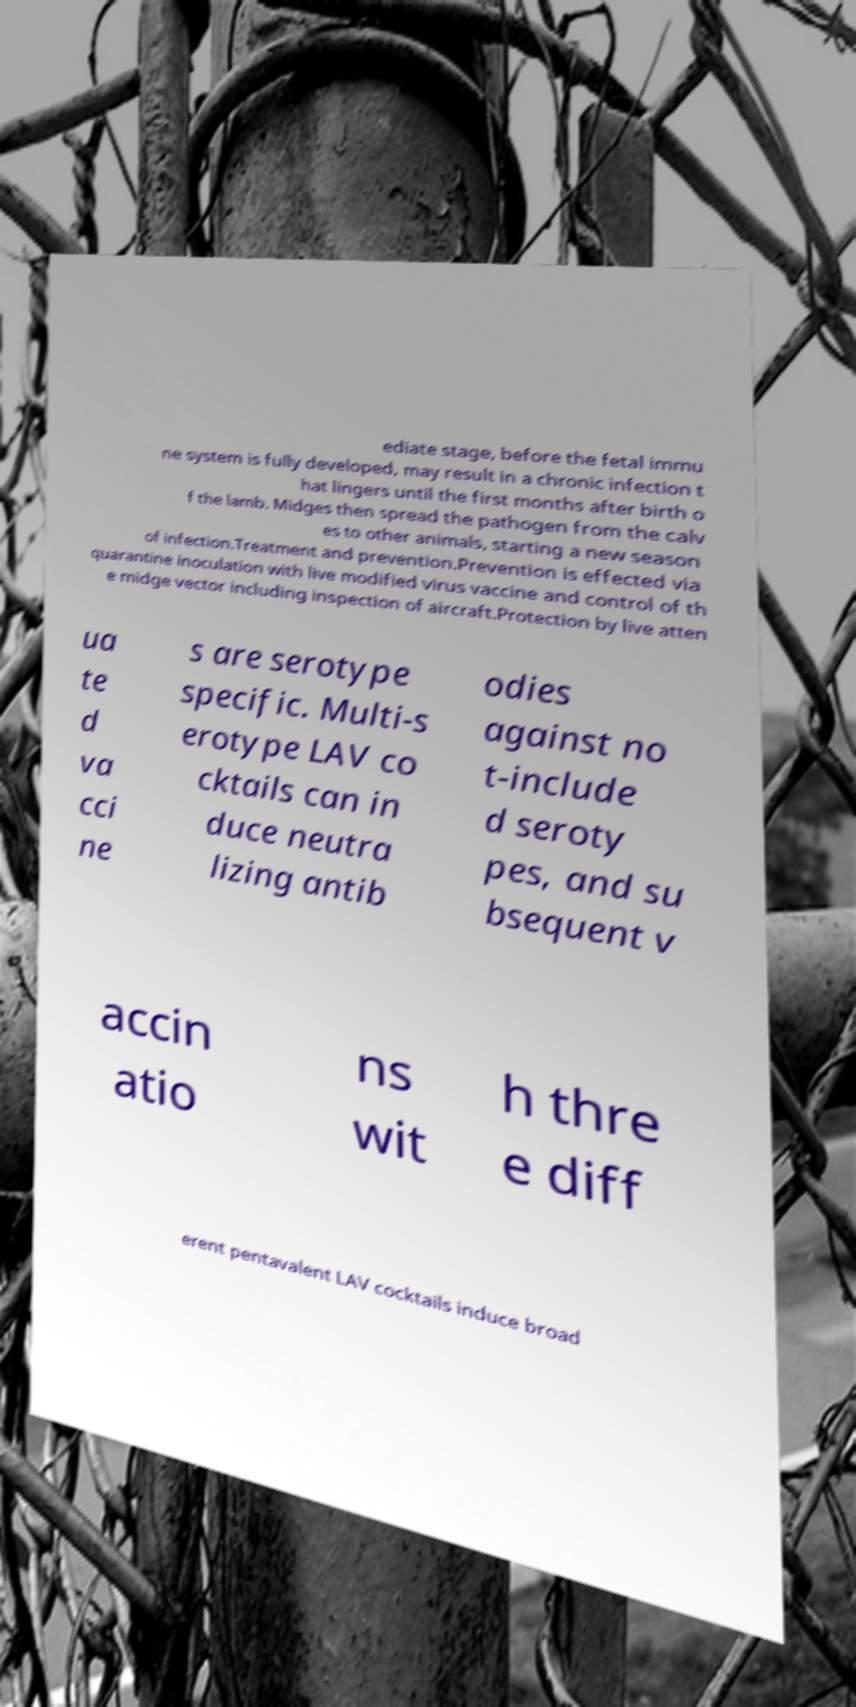There's text embedded in this image that I need extracted. Can you transcribe it verbatim? ediate stage, before the fetal immu ne system is fully developed, may result in a chronic infection t hat lingers until the first months after birth o f the lamb. Midges then spread the pathogen from the calv es to other animals, starting a new season of infection.Treatment and prevention.Prevention is effected via quarantine inoculation with live modified virus vaccine and control of th e midge vector including inspection of aircraft.Protection by live atten ua te d va cci ne s are serotype specific. Multi-s erotype LAV co cktails can in duce neutra lizing antib odies against no t-include d seroty pes, and su bsequent v accin atio ns wit h thre e diff erent pentavalent LAV cocktails induce broad 